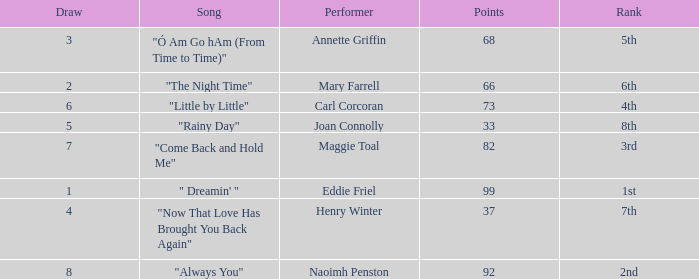Which song has more than 66 points, a draw greater than 3, and is ranked 3rd? "Come Back and Hold Me". 